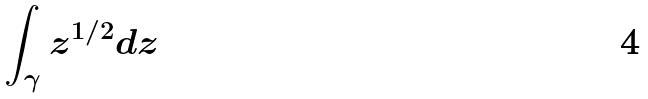<formula> <loc_0><loc_0><loc_500><loc_500>\int _ { \gamma } z ^ { 1 / 2 } d z</formula> 